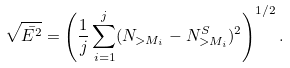<formula> <loc_0><loc_0><loc_500><loc_500>\sqrt { \bar { E ^ { 2 } } } = \left ( \frac { 1 } { j } \sum _ { i = 1 } ^ { j } ( N _ { > M _ { i } } - N ^ { S } _ { > M _ { i } } ) ^ { 2 } \right ) ^ { 1 / 2 } .</formula> 